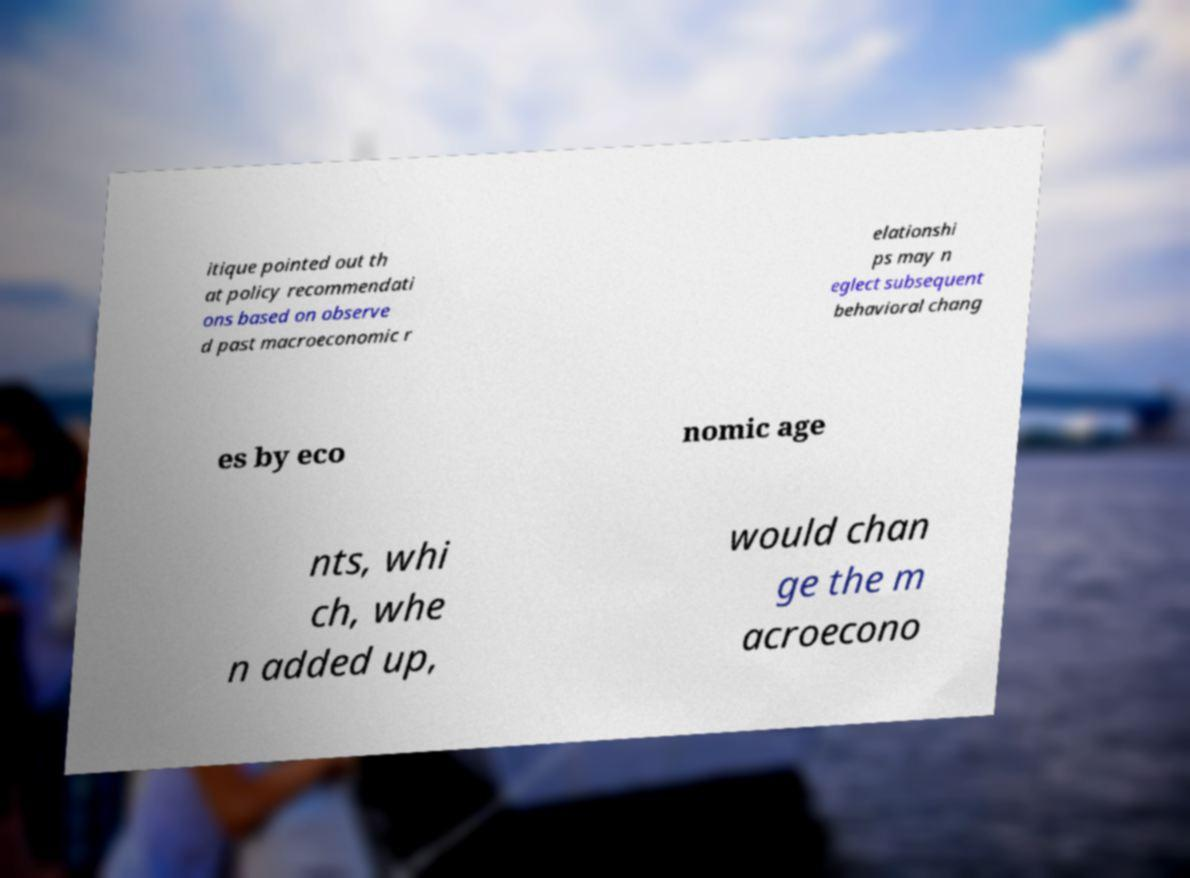Could you assist in decoding the text presented in this image and type it out clearly? itique pointed out th at policy recommendati ons based on observe d past macroeconomic r elationshi ps may n eglect subsequent behavioral chang es by eco nomic age nts, whi ch, whe n added up, would chan ge the m acroecono 